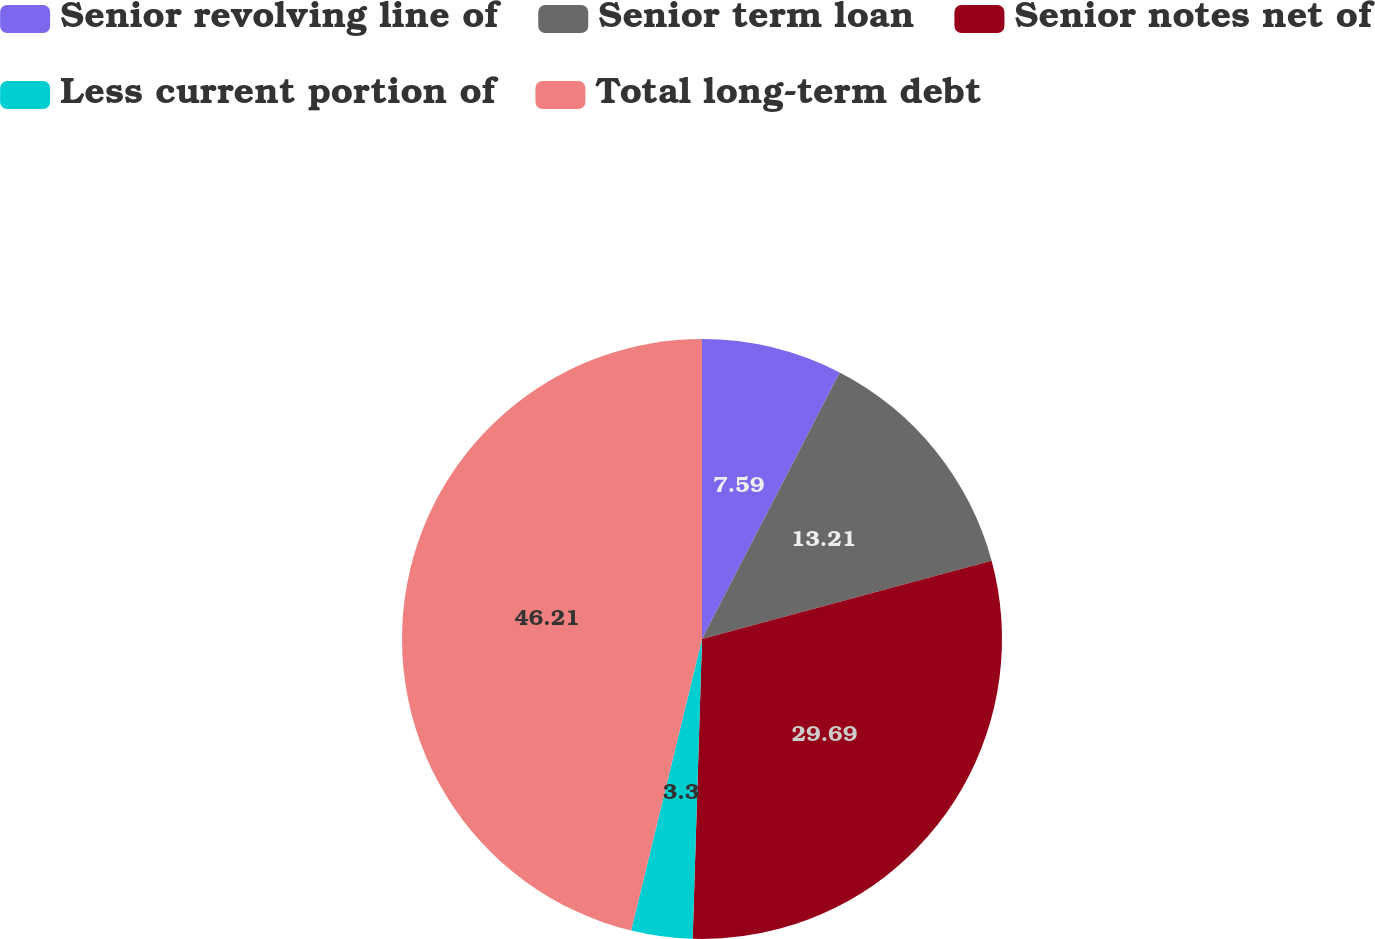Convert chart. <chart><loc_0><loc_0><loc_500><loc_500><pie_chart><fcel>Senior revolving line of<fcel>Senior term loan<fcel>Senior notes net of<fcel>Less current portion of<fcel>Total long-term debt<nl><fcel>7.59%<fcel>13.21%<fcel>29.69%<fcel>3.3%<fcel>46.2%<nl></chart> 